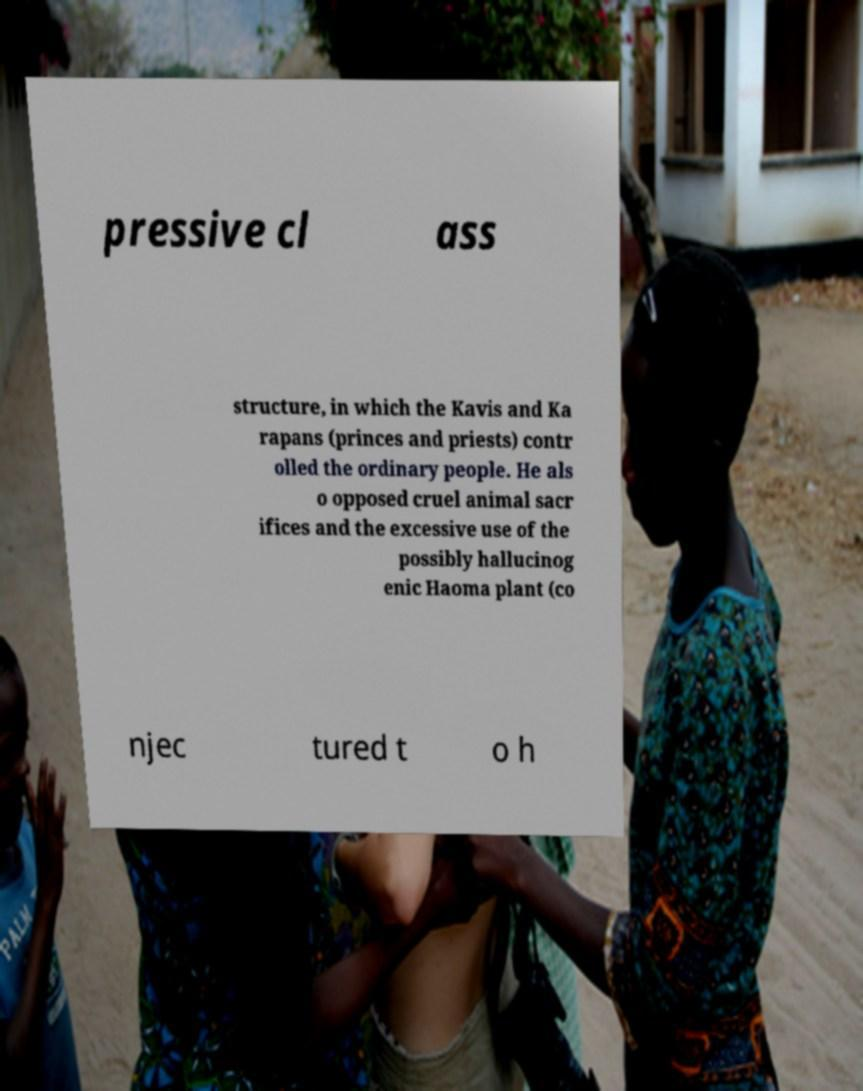There's text embedded in this image that I need extracted. Can you transcribe it verbatim? pressive cl ass structure, in which the Kavis and Ka rapans (princes and priests) contr olled the ordinary people. He als o opposed cruel animal sacr ifices and the excessive use of the possibly hallucinog enic Haoma plant (co njec tured t o h 